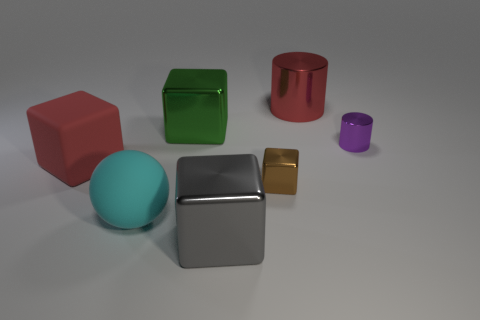Is there a block of the same size as the cyan rubber object?
Make the answer very short. Yes. There is a metal object that is on the right side of the big red metallic object; is its shape the same as the big red metal object?
Your answer should be compact. Yes. There is a big thing left of the rubber ball; what is its material?
Your answer should be compact. Rubber. There is a big object that is behind the shiny cube that is behind the small purple object; what is its shape?
Ensure brevity in your answer.  Cylinder. There is a large green shiny thing; does it have the same shape as the big red object that is behind the big green metal object?
Offer a very short reply. No. There is a large object that is behind the green block; what number of purple shiny cylinders are behind it?
Offer a terse response. 0. What is the material of the red thing that is the same shape as the green metallic thing?
Your answer should be very brief. Rubber. What number of brown objects are big cubes or big matte things?
Offer a terse response. 0. Are there any other things that have the same color as the small shiny block?
Keep it short and to the point. No. There is a big shiny object in front of the tiny object that is in front of the large matte cube; what is its color?
Keep it short and to the point. Gray. 